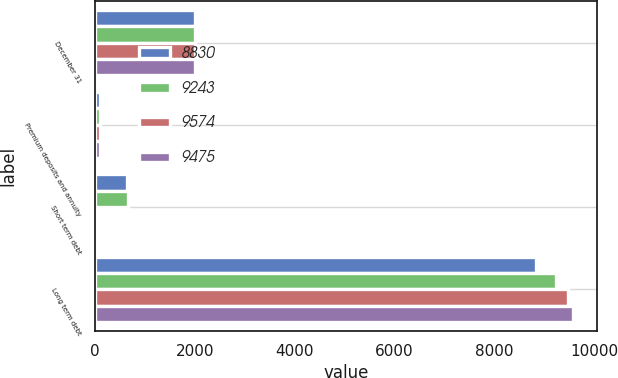<chart> <loc_0><loc_0><loc_500><loc_500><stacked_bar_chart><ecel><fcel>December 31<fcel>Premium deposits and annuity<fcel>Short term debt<fcel>Long term debt<nl><fcel>8830<fcel>2010<fcel>104<fcel>647<fcel>8830<nl><fcel>9243<fcel>2010<fcel>105<fcel>662<fcel>9243<nl><fcel>9574<fcel>2009<fcel>105<fcel>10<fcel>9475<nl><fcel>9475<fcel>2009<fcel>106<fcel>10<fcel>9574<nl></chart> 